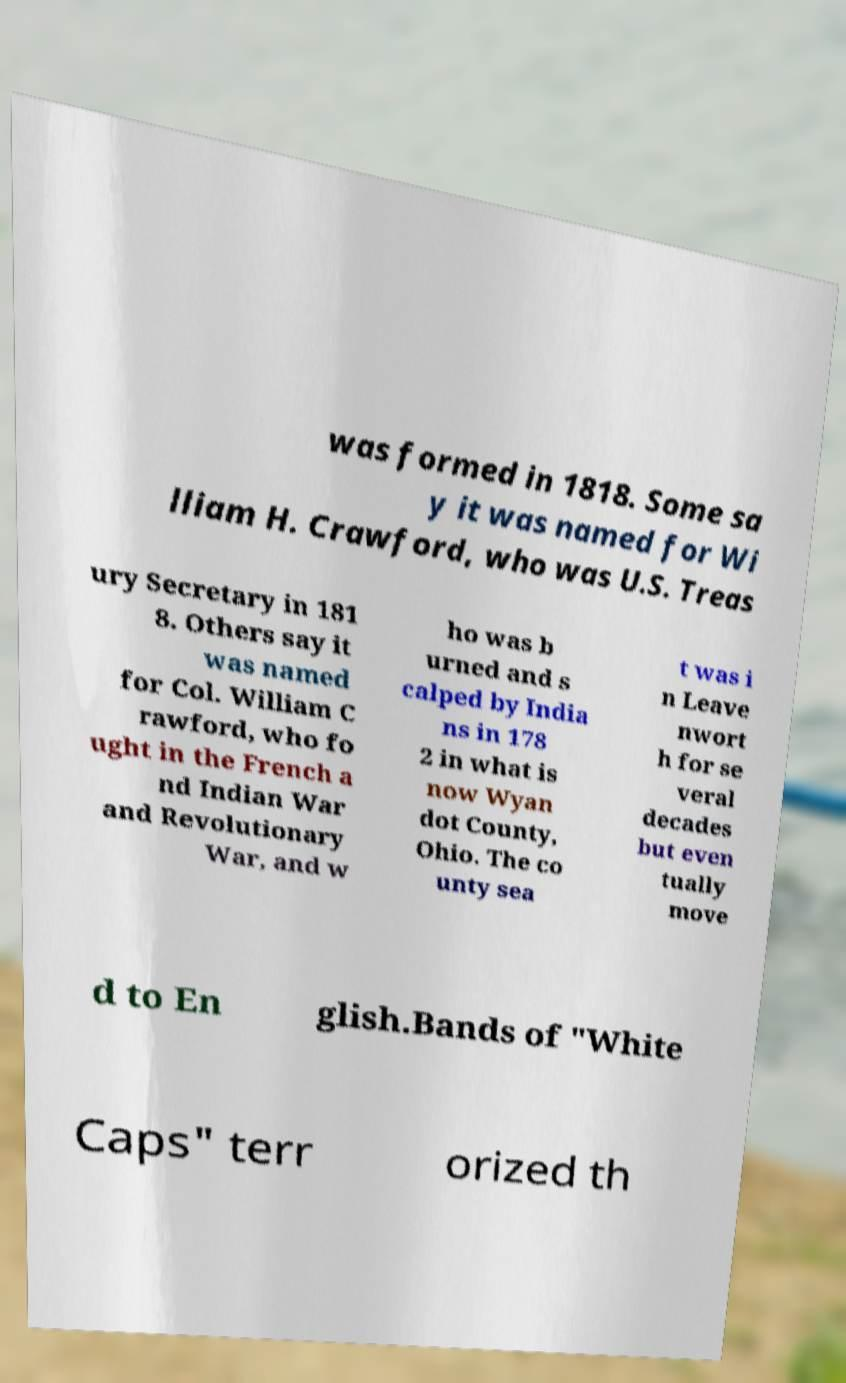Can you accurately transcribe the text from the provided image for me? was formed in 1818. Some sa y it was named for Wi lliam H. Crawford, who was U.S. Treas ury Secretary in 181 8. Others say it was named for Col. William C rawford, who fo ught in the French a nd Indian War and Revolutionary War, and w ho was b urned and s calped by India ns in 178 2 in what is now Wyan dot County, Ohio. The co unty sea t was i n Leave nwort h for se veral decades but even tually move d to En glish.Bands of "White Caps" terr orized th 